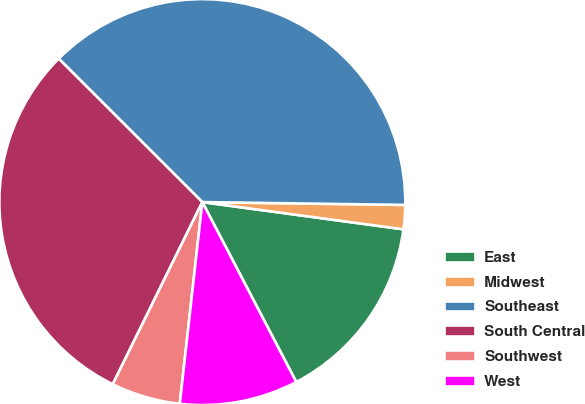<chart> <loc_0><loc_0><loc_500><loc_500><pie_chart><fcel>East<fcel>Midwest<fcel>Southeast<fcel>South Central<fcel>Southwest<fcel>West<nl><fcel>15.2%<fcel>1.92%<fcel>37.73%<fcel>30.22%<fcel>5.5%<fcel>9.43%<nl></chart> 